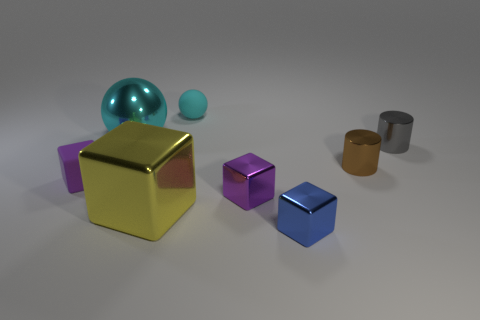Subtract all small blue metal cubes. How many cubes are left? 3 Subtract 2 cubes. How many cubes are left? 2 Subtract all yellow cylinders. How many purple cubes are left? 2 Subtract all yellow cubes. How many cubes are left? 3 Add 2 big yellow shiny cylinders. How many objects exist? 10 Subtract all spheres. How many objects are left? 6 Subtract all green blocks. Subtract all brown cylinders. How many blocks are left? 4 Add 6 tiny blue shiny blocks. How many tiny blue shiny blocks are left? 7 Add 7 gray blocks. How many gray blocks exist? 7 Subtract 0 green cylinders. How many objects are left? 8 